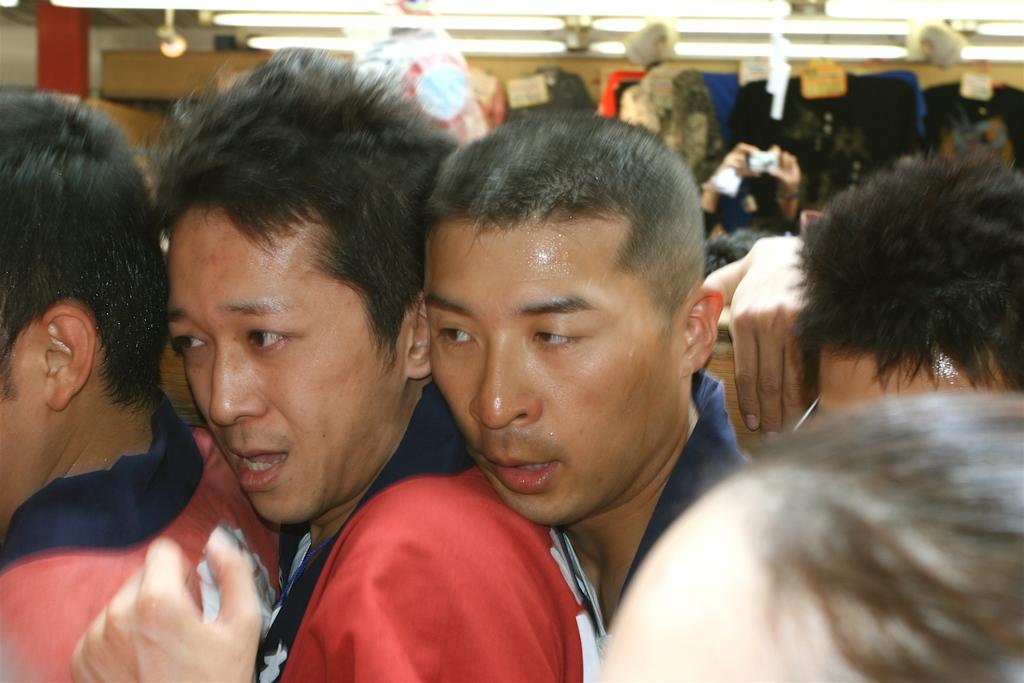What can be seen in the image? There are people, lights, and objects in the image. Can you describe the background of the image? The background of the image is blurry. What shape is the thought in the image? There is no reference to a shape or a thought in the image, so it is not possible to answer that question. 